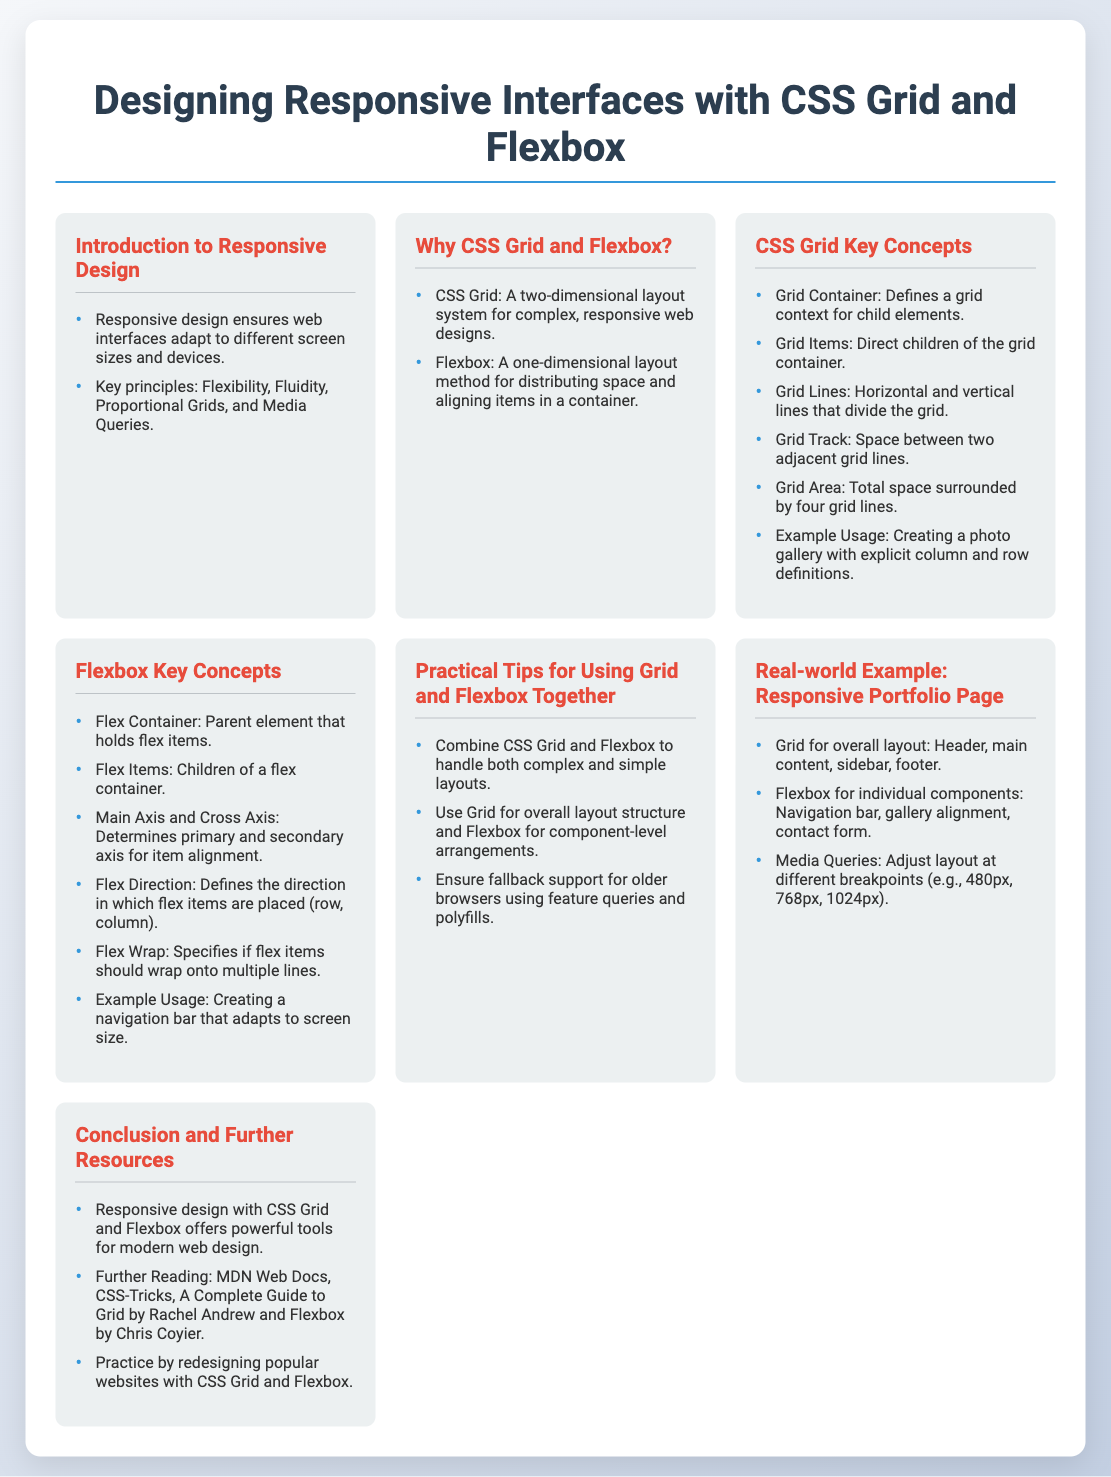What is the title of the presentation? The title is prominently displayed at the top of the document.
Answer: Designing Responsive Interfaces with CSS Grid and Flexbox What color is used for the headings? The headings in the document are styled with a specific color.
Answer: #2c3e50 How many key concepts are listed under CSS Grid? The document contains a specific number of listed concepts.
Answer: 6 What layout system is defined as a one-dimensional layout method? The document describes a specific layout system for aligning items.
Answer: Flexbox What is a practical tip for using Grid and Flexbox together? The document provides a concise strategy for layout management.
Answer: Combine CSS Grid and Flexbox What is one resource mentioned for further reading? The document includes specific resources for additional learning.
Answer: MDN Web Docs At what screen size does the grid switch to a single column layout? The document specifies a threshold for layout change.
Answer: 768px What is the main axis in Flexbox? The document outlines key terms related to Flexbox's structure.
Answer: Determines primary axis for item alignment 